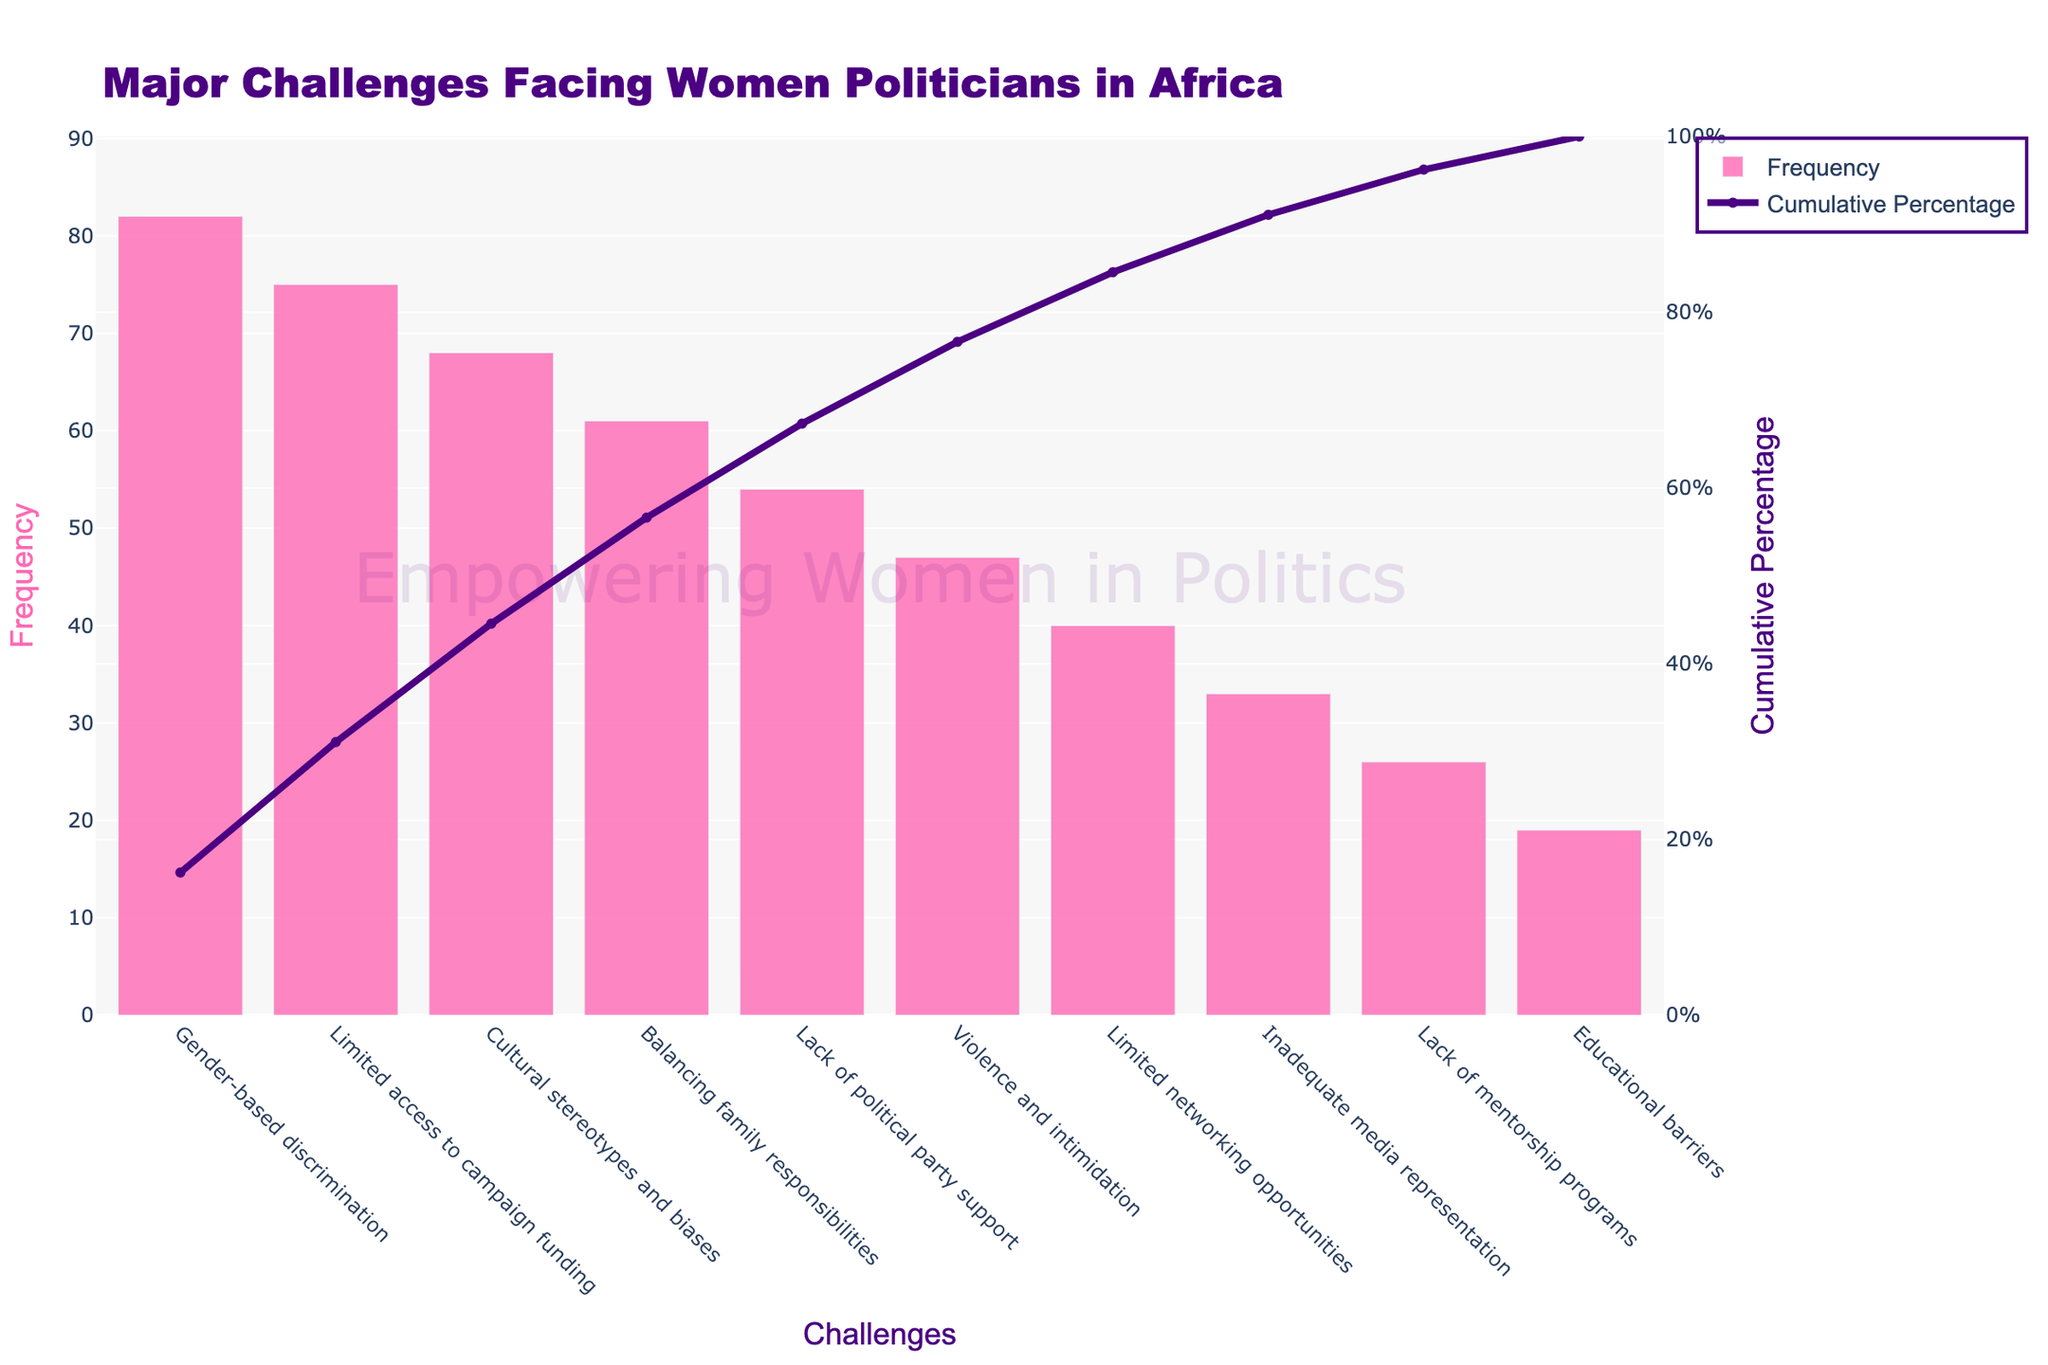What is the title of the Pareto chart? The title is displayed at the top of the chart and reads, 'Major Challenges Facing Women Politicians in Africa'.
Answer: Major Challenges Facing Women Politicians in Africa Which challenge has the highest frequency? By examining the tallest bar in the chart, we can see that 'Gender-based discrimination' has the highest frequency.
Answer: Gender-based discrimination How many challenges frequency are more than 50? The bars that exceed the frequency value of 50 are 'Gender-based discrimination', 'Limited access to campaign funding', 'Cultural stereotypes and biases', 'Balancing family responsibilities', and 'Lack of political party support'. Counting these gives us 5 challenges.
Answer: 5 What is the cumulative percentage value for the challenge 'Violence and intimidation'? By locating 'Violence and Intimidation' on the x-axis and moving upwards to the corresponding point on the line plot, we see that the cumulative percentage is around 66%.
Answer: 66% What is the range of the y-axis on the left side of the chart? The y-axis on the left side of the chart ranges from the minimum value of 0 to a maximum value slightly above the highest frequency, which is around 90 (10% higher than 82).
Answer: 0 to 90 What is the lowest frequency challenge listed in the chart? The shortest bar represents 'Educational barriers', which has the lowest frequency of 19.
Answer: Educational barriers How many challenges have a cumulative percentage less than 50%? We follow the line plot and observe the cumulative percentages. 'Gender-based discrimination', 'Limited access to campaign funding', and 'Cultural stereotypes and biases' all have their cumulative percentage less than 50% which totals to 3 challenges.
Answer: 3 By what percentage does 'Inadequate media representation' increase the cumulative total from the previous challenge? We find the cumulative percentages of 'Inadequate media representation' and the preceding challenge ('Limited networking opportunities'). 'Inadequate media representation' reaches approximately 82%, while 'Limited networking opportunities' is approximately 70%. The increase is around 12%.
Answer: 12% Which challenge has a higher frequency: 'Balancing family responsibilities' or 'Violence and intimidation'? By comparing the heights of the bars for 'Balancing family responsibilities' and 'Violence and intimidation', we see that 'Balancing family responsibilities' has a higher frequency (61 versus 47).
Answer: Balancing family responsibilities What is the cumulative percentage after including the 'Balancing family responsibilities' challenge? We locate 'Balancing family responsibilities' and follow its corresponding line plot point which intersects around 77%.
Answer: 77% 